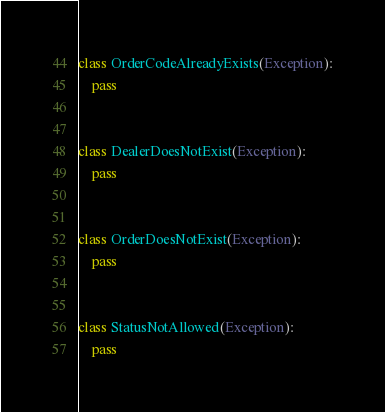<code> <loc_0><loc_0><loc_500><loc_500><_Python_>class OrderCodeAlreadyExists(Exception):
    pass


class DealerDoesNotExist(Exception):
    pass


class OrderDoesNotExist(Exception):
    pass


class StatusNotAllowed(Exception):
    pass
</code> 